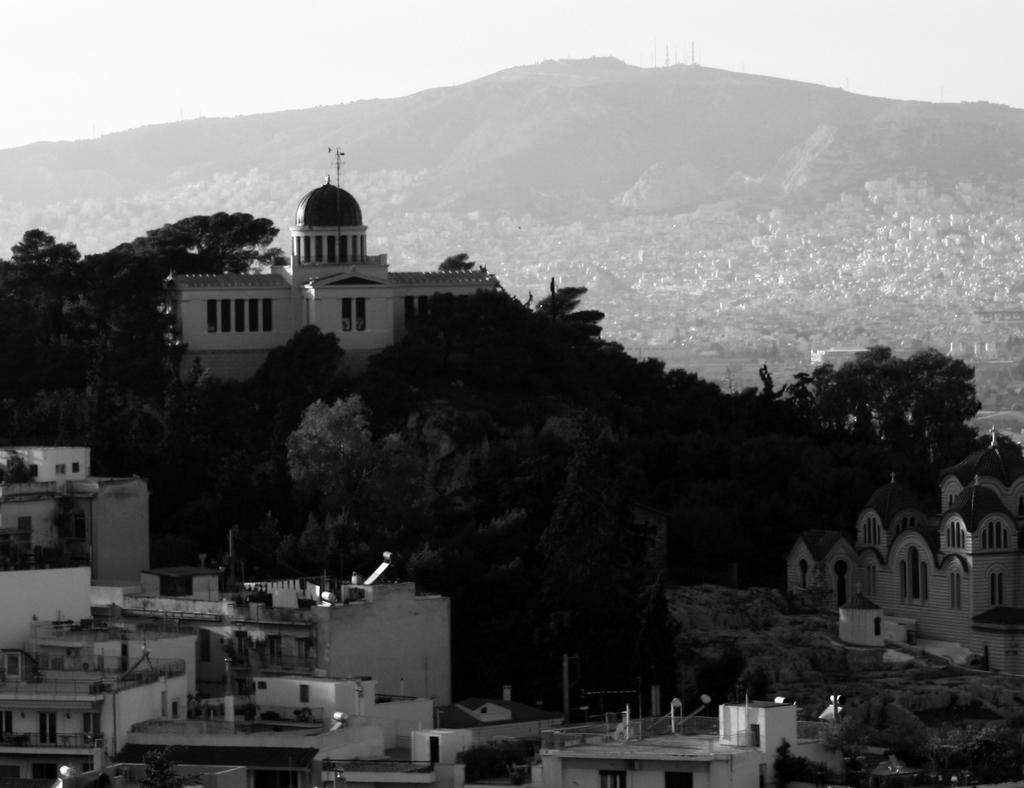How would you summarize this image in a sentence or two? In this image in the center there are buildings.,trees and in the background there are mountains and the sky is cloudy. 